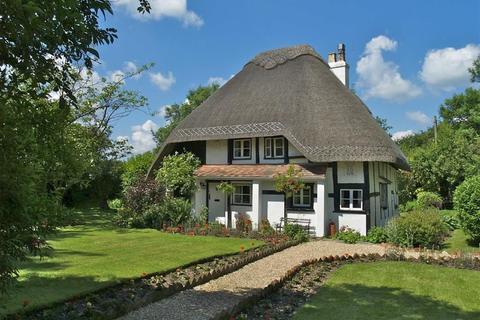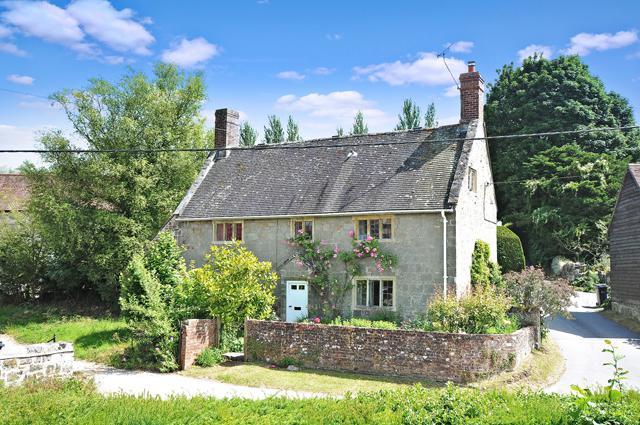The first image is the image on the left, the second image is the image on the right. Assess this claim about the two images: "In the center of each image there is a house surrounded by a lot of green foliage and landscaping.". Correct or not? Answer yes or no. Yes. The first image is the image on the left, the second image is the image on the right. For the images displayed, is the sentence "In at least one image there are a total of five window on the main house at atleast one chimney ." factually correct? Answer yes or no. Yes. 